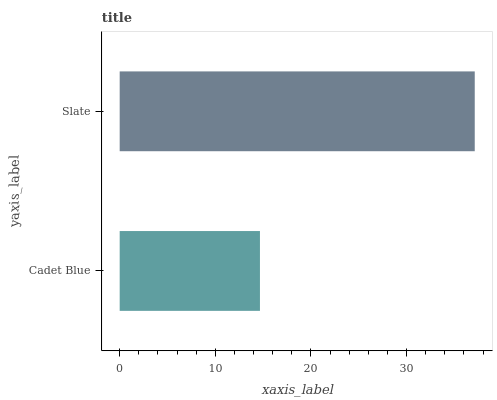Is Cadet Blue the minimum?
Answer yes or no. Yes. Is Slate the maximum?
Answer yes or no. Yes. Is Slate the minimum?
Answer yes or no. No. Is Slate greater than Cadet Blue?
Answer yes or no. Yes. Is Cadet Blue less than Slate?
Answer yes or no. Yes. Is Cadet Blue greater than Slate?
Answer yes or no. No. Is Slate less than Cadet Blue?
Answer yes or no. No. Is Slate the high median?
Answer yes or no. Yes. Is Cadet Blue the low median?
Answer yes or no. Yes. Is Cadet Blue the high median?
Answer yes or no. No. Is Slate the low median?
Answer yes or no. No. 